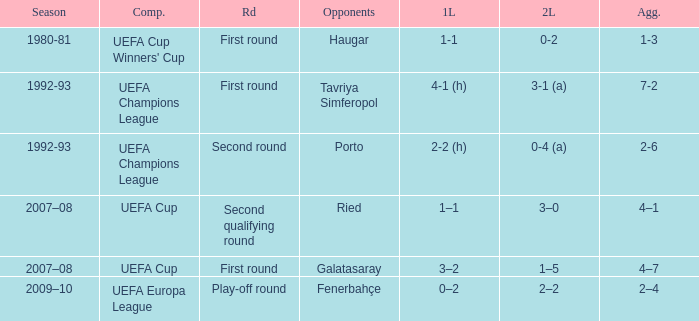What is the total number of 2nd leg where aggregate is 7-2 1.0. 